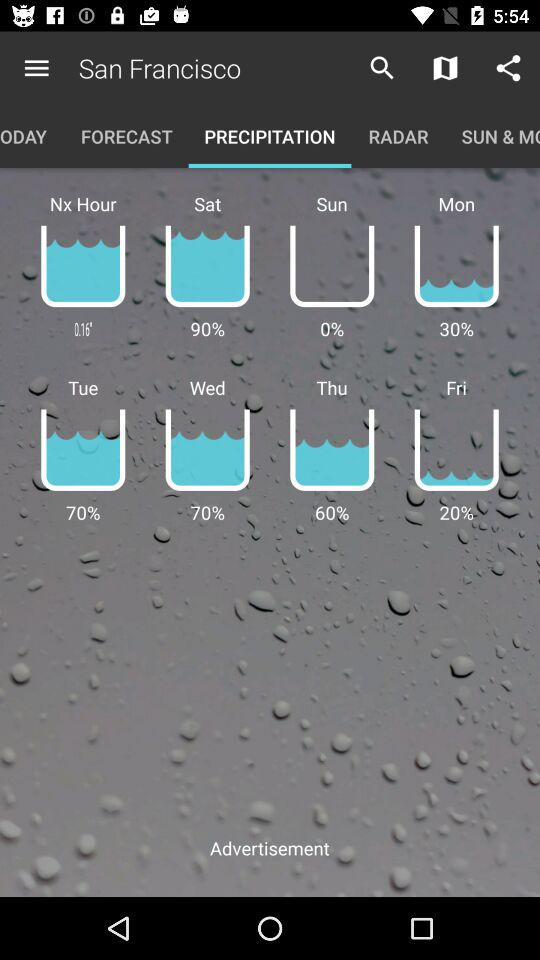On what day is there 60% precipitation? The day is Thursday. 